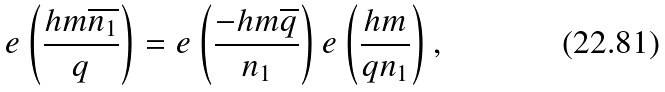Convert formula to latex. <formula><loc_0><loc_0><loc_500><loc_500>e \left ( \frac { h m \overline { n _ { 1 } } } { q } \right ) = e \left ( \frac { - h m \overline { q } } { n _ { 1 } } \right ) e \left ( \frac { h m } { q n _ { 1 } } \right ) ,</formula> 